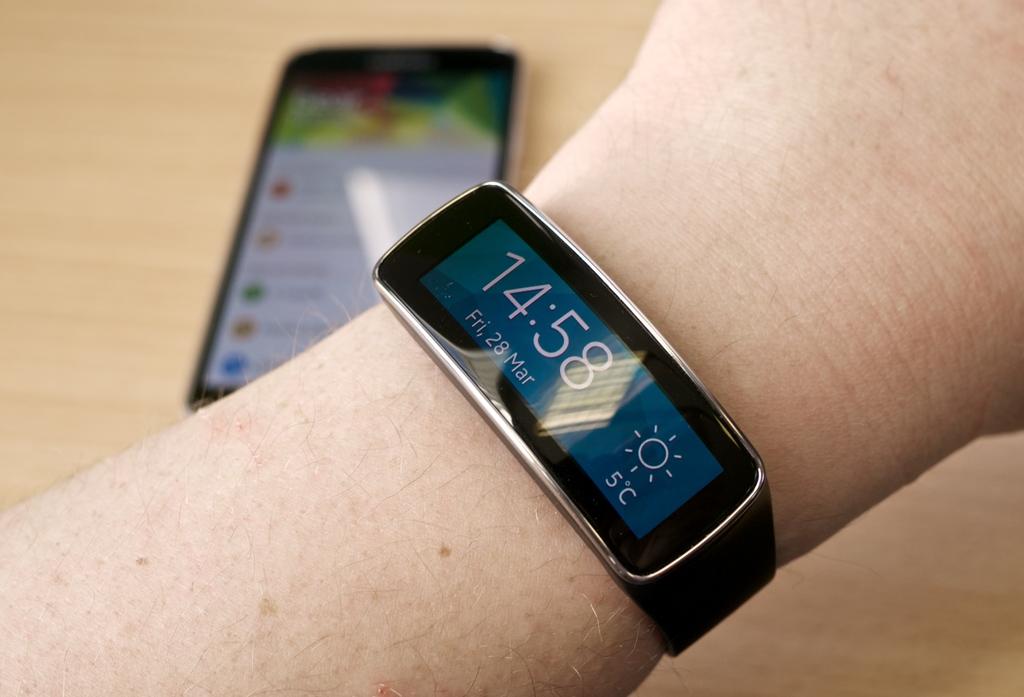What temperature does it say on the watch?
Your response must be concise. 5 c. What time does the watch say it is?
Offer a terse response. 14:58. 